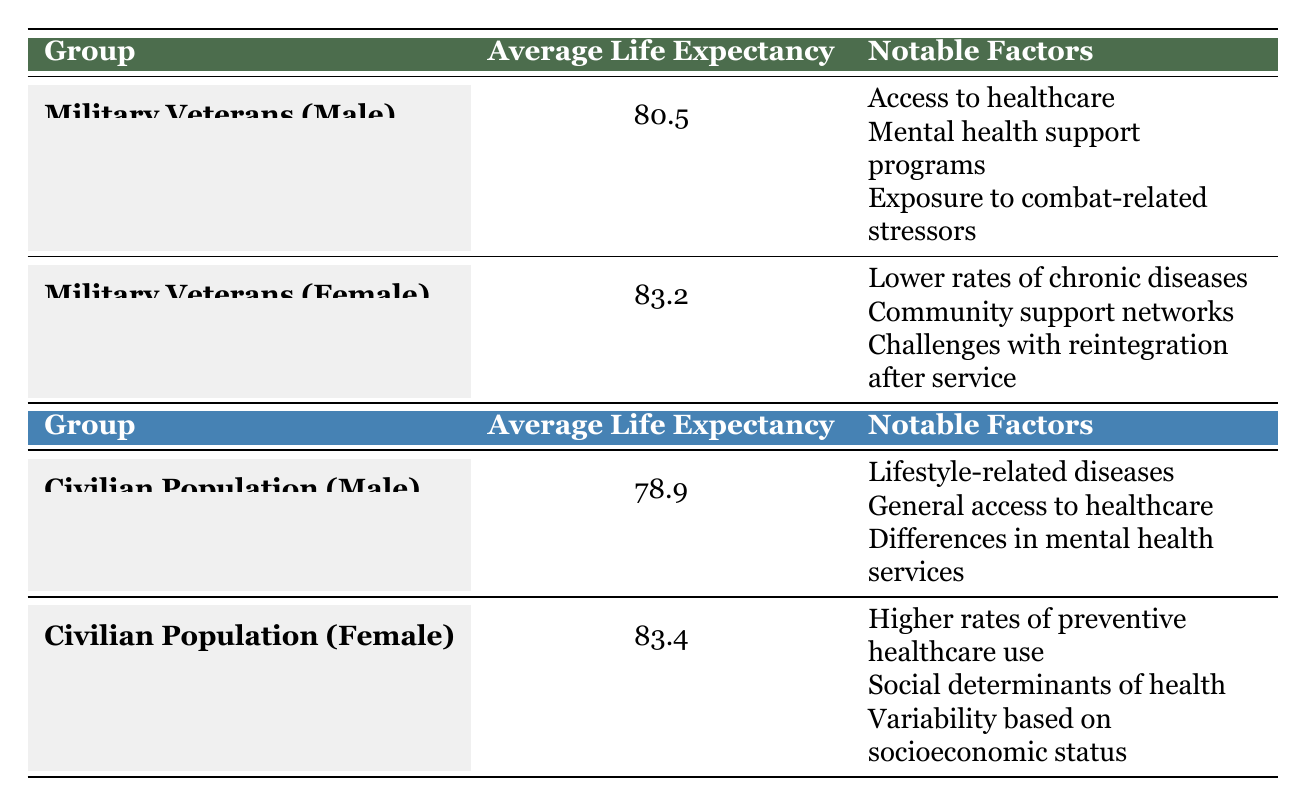What is the average life expectancy of male military veterans? The table lists the average life expectancy for male military veterans as 80.5 years.
Answer: 80.5 Which demographic group has the highest average life expectancy? Comparing the average life expectancy values, female military veterans have an average of 83.2 years, which is higher than female civilians at 83.4 years, although the latter is slightly higher.
Answer: Female civilian population True or False: Male civilians have a higher average life expectancy than male military veterans. The average life expectancy for male civilians is 78.9 years, which is lower than that of male military veterans at 80.5 years. Therefore, the statement is false.
Answer: False What is the difference in life expectancy between female military veterans and female civilians? The average life expectancy for female military veterans is 83.2 years, and for female civilians, it is 83.4 years. The difference is 83.4 - 83.2 = 0.2 years.
Answer: 0.2 years What notable factor is associated with male military veterans? The notable factors listed for male military veterans include access to healthcare, mental health support programs, and exposure to combat-related stressors.
Answer: Access to healthcare What is the average life expectancy of the civilian population, both male and female combined? The average life expectancy for male civilians is 78.9 years and for female civilians is 83.4 years. The combined average is (78.9 + 83.4) / 2 = 81.15 years.
Answer: 81.15 True or False: Both male and female military veterans have higher average life expectancies than their civilian counterparts. Male military veterans have an average life expectancy of 80.5 years, which is higher than male civilians at 78.9 years. Female military veterans have 83.2 years compared to female civilians at 83.4 years, which is lower. Thus, the statement is partially true.
Answer: False Which group has lower rates of chronic diseases according to the table? The table indicates that female military veterans have lower rates of chronic diseases as one of their notable factors.
Answer: Female military veterans What factor contributes to the higher average life expectancy of female civilians? The notable factors for female civilians include higher rates of preventive healthcare use and social determinants of health, which contribute to their higher average life expectancy.
Answer: Higher rates of preventive healthcare use 